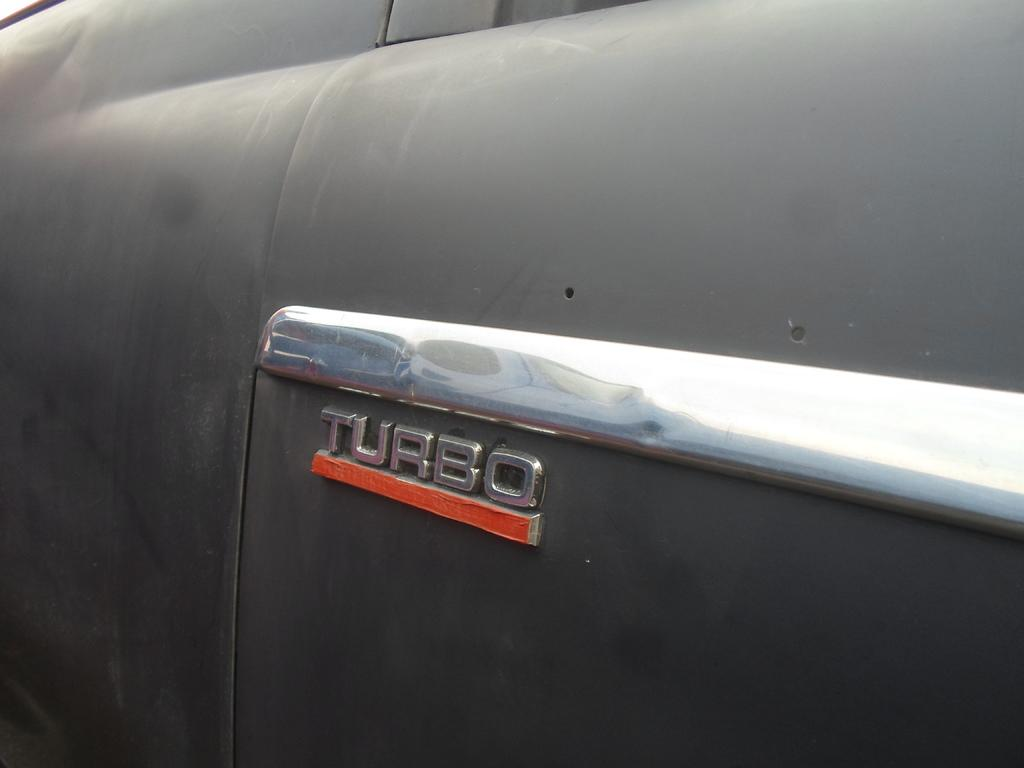What is the color of the object in the picture? The object in the picture is black. What is featured on the black object? There is a logo on the black object. What type of silk material is used to make the sidewalk in the image? There is no mention of silk or a sidewalk in the image; it features a black object with a logo. 